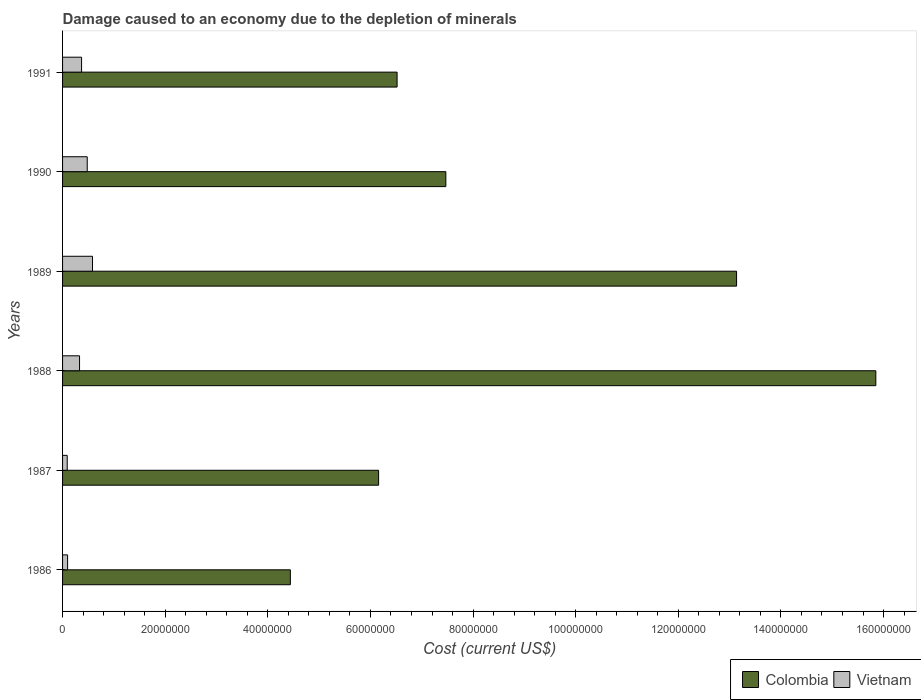How many different coloured bars are there?
Your answer should be compact. 2. How many groups of bars are there?
Make the answer very short. 6. Are the number of bars per tick equal to the number of legend labels?
Ensure brevity in your answer.  Yes. Are the number of bars on each tick of the Y-axis equal?
Provide a short and direct response. Yes. How many bars are there on the 5th tick from the bottom?
Your answer should be compact. 2. What is the cost of damage caused due to the depletion of minerals in Vietnam in 1986?
Provide a short and direct response. 9.79e+05. Across all years, what is the maximum cost of damage caused due to the depletion of minerals in Colombia?
Your response must be concise. 1.59e+08. Across all years, what is the minimum cost of damage caused due to the depletion of minerals in Colombia?
Provide a succinct answer. 4.44e+07. In which year was the cost of damage caused due to the depletion of minerals in Colombia maximum?
Make the answer very short. 1988. In which year was the cost of damage caused due to the depletion of minerals in Vietnam minimum?
Your response must be concise. 1987. What is the total cost of damage caused due to the depletion of minerals in Vietnam in the graph?
Provide a succinct answer. 1.95e+07. What is the difference between the cost of damage caused due to the depletion of minerals in Vietnam in 1987 and that in 1991?
Provide a succinct answer. -2.80e+06. What is the difference between the cost of damage caused due to the depletion of minerals in Colombia in 1991 and the cost of damage caused due to the depletion of minerals in Vietnam in 1989?
Make the answer very short. 5.94e+07. What is the average cost of damage caused due to the depletion of minerals in Vietnam per year?
Offer a terse response. 3.26e+06. In the year 1990, what is the difference between the cost of damage caused due to the depletion of minerals in Vietnam and cost of damage caused due to the depletion of minerals in Colombia?
Offer a terse response. -6.99e+07. In how many years, is the cost of damage caused due to the depletion of minerals in Colombia greater than 40000000 US$?
Your response must be concise. 6. What is the ratio of the cost of damage caused due to the depletion of minerals in Vietnam in 1986 to that in 1987?
Offer a very short reply. 1.08. Is the cost of damage caused due to the depletion of minerals in Colombia in 1986 less than that in 1989?
Make the answer very short. Yes. What is the difference between the highest and the second highest cost of damage caused due to the depletion of minerals in Colombia?
Make the answer very short. 2.71e+07. What is the difference between the highest and the lowest cost of damage caused due to the depletion of minerals in Vietnam?
Your response must be concise. 4.93e+06. In how many years, is the cost of damage caused due to the depletion of minerals in Colombia greater than the average cost of damage caused due to the depletion of minerals in Colombia taken over all years?
Provide a succinct answer. 2. Is the sum of the cost of damage caused due to the depletion of minerals in Colombia in 1988 and 1990 greater than the maximum cost of damage caused due to the depletion of minerals in Vietnam across all years?
Keep it short and to the point. Yes. What does the 1st bar from the top in 1990 represents?
Your answer should be compact. Vietnam. What does the 2nd bar from the bottom in 1990 represents?
Make the answer very short. Vietnam. How many bars are there?
Provide a succinct answer. 12. Are all the bars in the graph horizontal?
Make the answer very short. Yes. What is the difference between two consecutive major ticks on the X-axis?
Offer a very short reply. 2.00e+07. Does the graph contain any zero values?
Make the answer very short. No. How are the legend labels stacked?
Provide a succinct answer. Horizontal. What is the title of the graph?
Your response must be concise. Damage caused to an economy due to the depletion of minerals. Does "French Polynesia" appear as one of the legend labels in the graph?
Offer a very short reply. No. What is the label or title of the X-axis?
Make the answer very short. Cost (current US$). What is the label or title of the Y-axis?
Provide a short and direct response. Years. What is the Cost (current US$) of Colombia in 1986?
Offer a very short reply. 4.44e+07. What is the Cost (current US$) in Vietnam in 1986?
Your answer should be very brief. 9.79e+05. What is the Cost (current US$) in Colombia in 1987?
Ensure brevity in your answer.  6.16e+07. What is the Cost (current US$) in Vietnam in 1987?
Keep it short and to the point. 9.07e+05. What is the Cost (current US$) in Colombia in 1988?
Your answer should be compact. 1.59e+08. What is the Cost (current US$) of Vietnam in 1988?
Your response must be concise. 3.31e+06. What is the Cost (current US$) in Colombia in 1989?
Keep it short and to the point. 1.31e+08. What is the Cost (current US$) in Vietnam in 1989?
Ensure brevity in your answer.  5.84e+06. What is the Cost (current US$) in Colombia in 1990?
Offer a very short reply. 7.47e+07. What is the Cost (current US$) of Vietnam in 1990?
Provide a short and direct response. 4.81e+06. What is the Cost (current US$) in Colombia in 1991?
Offer a very short reply. 6.52e+07. What is the Cost (current US$) in Vietnam in 1991?
Offer a terse response. 3.71e+06. Across all years, what is the maximum Cost (current US$) of Colombia?
Make the answer very short. 1.59e+08. Across all years, what is the maximum Cost (current US$) in Vietnam?
Your answer should be very brief. 5.84e+06. Across all years, what is the minimum Cost (current US$) of Colombia?
Ensure brevity in your answer.  4.44e+07. Across all years, what is the minimum Cost (current US$) in Vietnam?
Keep it short and to the point. 9.07e+05. What is the total Cost (current US$) of Colombia in the graph?
Keep it short and to the point. 5.36e+08. What is the total Cost (current US$) in Vietnam in the graph?
Your response must be concise. 1.95e+07. What is the difference between the Cost (current US$) of Colombia in 1986 and that in 1987?
Your answer should be compact. -1.72e+07. What is the difference between the Cost (current US$) of Vietnam in 1986 and that in 1987?
Give a very brief answer. 7.11e+04. What is the difference between the Cost (current US$) of Colombia in 1986 and that in 1988?
Your answer should be very brief. -1.14e+08. What is the difference between the Cost (current US$) of Vietnam in 1986 and that in 1988?
Offer a terse response. -2.33e+06. What is the difference between the Cost (current US$) of Colombia in 1986 and that in 1989?
Keep it short and to the point. -8.70e+07. What is the difference between the Cost (current US$) of Vietnam in 1986 and that in 1989?
Offer a terse response. -4.86e+06. What is the difference between the Cost (current US$) of Colombia in 1986 and that in 1990?
Your answer should be very brief. -3.03e+07. What is the difference between the Cost (current US$) of Vietnam in 1986 and that in 1990?
Offer a terse response. -3.83e+06. What is the difference between the Cost (current US$) of Colombia in 1986 and that in 1991?
Your answer should be compact. -2.08e+07. What is the difference between the Cost (current US$) of Vietnam in 1986 and that in 1991?
Offer a very short reply. -2.73e+06. What is the difference between the Cost (current US$) in Colombia in 1987 and that in 1988?
Your answer should be compact. -9.69e+07. What is the difference between the Cost (current US$) of Vietnam in 1987 and that in 1988?
Offer a very short reply. -2.40e+06. What is the difference between the Cost (current US$) in Colombia in 1987 and that in 1989?
Offer a very short reply. -6.98e+07. What is the difference between the Cost (current US$) in Vietnam in 1987 and that in 1989?
Ensure brevity in your answer.  -4.93e+06. What is the difference between the Cost (current US$) of Colombia in 1987 and that in 1990?
Give a very brief answer. -1.31e+07. What is the difference between the Cost (current US$) in Vietnam in 1987 and that in 1990?
Your answer should be compact. -3.90e+06. What is the difference between the Cost (current US$) of Colombia in 1987 and that in 1991?
Make the answer very short. -3.60e+06. What is the difference between the Cost (current US$) of Vietnam in 1987 and that in 1991?
Provide a short and direct response. -2.80e+06. What is the difference between the Cost (current US$) in Colombia in 1988 and that in 1989?
Your answer should be compact. 2.71e+07. What is the difference between the Cost (current US$) in Vietnam in 1988 and that in 1989?
Your answer should be compact. -2.53e+06. What is the difference between the Cost (current US$) in Colombia in 1988 and that in 1990?
Offer a terse response. 8.38e+07. What is the difference between the Cost (current US$) in Vietnam in 1988 and that in 1990?
Provide a succinct answer. -1.50e+06. What is the difference between the Cost (current US$) in Colombia in 1988 and that in 1991?
Ensure brevity in your answer.  9.33e+07. What is the difference between the Cost (current US$) of Vietnam in 1988 and that in 1991?
Your answer should be very brief. -3.96e+05. What is the difference between the Cost (current US$) in Colombia in 1989 and that in 1990?
Give a very brief answer. 5.67e+07. What is the difference between the Cost (current US$) of Vietnam in 1989 and that in 1990?
Your answer should be very brief. 1.03e+06. What is the difference between the Cost (current US$) in Colombia in 1989 and that in 1991?
Offer a very short reply. 6.62e+07. What is the difference between the Cost (current US$) of Vietnam in 1989 and that in 1991?
Ensure brevity in your answer.  2.13e+06. What is the difference between the Cost (current US$) of Colombia in 1990 and that in 1991?
Provide a short and direct response. 9.50e+06. What is the difference between the Cost (current US$) in Vietnam in 1990 and that in 1991?
Provide a succinct answer. 1.10e+06. What is the difference between the Cost (current US$) in Colombia in 1986 and the Cost (current US$) in Vietnam in 1987?
Ensure brevity in your answer.  4.35e+07. What is the difference between the Cost (current US$) of Colombia in 1986 and the Cost (current US$) of Vietnam in 1988?
Your response must be concise. 4.11e+07. What is the difference between the Cost (current US$) of Colombia in 1986 and the Cost (current US$) of Vietnam in 1989?
Your answer should be compact. 3.86e+07. What is the difference between the Cost (current US$) of Colombia in 1986 and the Cost (current US$) of Vietnam in 1990?
Your answer should be very brief. 3.96e+07. What is the difference between the Cost (current US$) of Colombia in 1986 and the Cost (current US$) of Vietnam in 1991?
Your answer should be compact. 4.07e+07. What is the difference between the Cost (current US$) in Colombia in 1987 and the Cost (current US$) in Vietnam in 1988?
Ensure brevity in your answer.  5.83e+07. What is the difference between the Cost (current US$) in Colombia in 1987 and the Cost (current US$) in Vietnam in 1989?
Your response must be concise. 5.58e+07. What is the difference between the Cost (current US$) in Colombia in 1987 and the Cost (current US$) in Vietnam in 1990?
Give a very brief answer. 5.68e+07. What is the difference between the Cost (current US$) of Colombia in 1987 and the Cost (current US$) of Vietnam in 1991?
Offer a terse response. 5.79e+07. What is the difference between the Cost (current US$) in Colombia in 1988 and the Cost (current US$) in Vietnam in 1989?
Provide a succinct answer. 1.53e+08. What is the difference between the Cost (current US$) of Colombia in 1988 and the Cost (current US$) of Vietnam in 1990?
Your response must be concise. 1.54e+08. What is the difference between the Cost (current US$) in Colombia in 1988 and the Cost (current US$) in Vietnam in 1991?
Provide a succinct answer. 1.55e+08. What is the difference between the Cost (current US$) of Colombia in 1989 and the Cost (current US$) of Vietnam in 1990?
Offer a terse response. 1.27e+08. What is the difference between the Cost (current US$) in Colombia in 1989 and the Cost (current US$) in Vietnam in 1991?
Offer a terse response. 1.28e+08. What is the difference between the Cost (current US$) of Colombia in 1990 and the Cost (current US$) of Vietnam in 1991?
Provide a succinct answer. 7.10e+07. What is the average Cost (current US$) of Colombia per year?
Keep it short and to the point. 8.93e+07. What is the average Cost (current US$) in Vietnam per year?
Make the answer very short. 3.26e+06. In the year 1986, what is the difference between the Cost (current US$) in Colombia and Cost (current US$) in Vietnam?
Your response must be concise. 4.34e+07. In the year 1987, what is the difference between the Cost (current US$) in Colombia and Cost (current US$) in Vietnam?
Give a very brief answer. 6.07e+07. In the year 1988, what is the difference between the Cost (current US$) in Colombia and Cost (current US$) in Vietnam?
Give a very brief answer. 1.55e+08. In the year 1989, what is the difference between the Cost (current US$) in Colombia and Cost (current US$) in Vietnam?
Ensure brevity in your answer.  1.26e+08. In the year 1990, what is the difference between the Cost (current US$) in Colombia and Cost (current US$) in Vietnam?
Your answer should be very brief. 6.99e+07. In the year 1991, what is the difference between the Cost (current US$) in Colombia and Cost (current US$) in Vietnam?
Offer a very short reply. 6.15e+07. What is the ratio of the Cost (current US$) of Colombia in 1986 to that in 1987?
Your response must be concise. 0.72. What is the ratio of the Cost (current US$) of Vietnam in 1986 to that in 1987?
Offer a very short reply. 1.08. What is the ratio of the Cost (current US$) of Colombia in 1986 to that in 1988?
Provide a short and direct response. 0.28. What is the ratio of the Cost (current US$) in Vietnam in 1986 to that in 1988?
Your answer should be very brief. 0.3. What is the ratio of the Cost (current US$) of Colombia in 1986 to that in 1989?
Give a very brief answer. 0.34. What is the ratio of the Cost (current US$) of Vietnam in 1986 to that in 1989?
Give a very brief answer. 0.17. What is the ratio of the Cost (current US$) of Colombia in 1986 to that in 1990?
Your answer should be compact. 0.59. What is the ratio of the Cost (current US$) in Vietnam in 1986 to that in 1990?
Your response must be concise. 0.2. What is the ratio of the Cost (current US$) in Colombia in 1986 to that in 1991?
Give a very brief answer. 0.68. What is the ratio of the Cost (current US$) in Vietnam in 1986 to that in 1991?
Your response must be concise. 0.26. What is the ratio of the Cost (current US$) of Colombia in 1987 to that in 1988?
Your answer should be very brief. 0.39. What is the ratio of the Cost (current US$) of Vietnam in 1987 to that in 1988?
Your answer should be very brief. 0.27. What is the ratio of the Cost (current US$) of Colombia in 1987 to that in 1989?
Provide a short and direct response. 0.47. What is the ratio of the Cost (current US$) of Vietnam in 1987 to that in 1989?
Provide a succinct answer. 0.16. What is the ratio of the Cost (current US$) of Colombia in 1987 to that in 1990?
Ensure brevity in your answer.  0.82. What is the ratio of the Cost (current US$) in Vietnam in 1987 to that in 1990?
Keep it short and to the point. 0.19. What is the ratio of the Cost (current US$) in Colombia in 1987 to that in 1991?
Ensure brevity in your answer.  0.94. What is the ratio of the Cost (current US$) in Vietnam in 1987 to that in 1991?
Your answer should be very brief. 0.24. What is the ratio of the Cost (current US$) in Colombia in 1988 to that in 1989?
Provide a succinct answer. 1.21. What is the ratio of the Cost (current US$) in Vietnam in 1988 to that in 1989?
Provide a succinct answer. 0.57. What is the ratio of the Cost (current US$) in Colombia in 1988 to that in 1990?
Make the answer very short. 2.12. What is the ratio of the Cost (current US$) in Vietnam in 1988 to that in 1990?
Make the answer very short. 0.69. What is the ratio of the Cost (current US$) in Colombia in 1988 to that in 1991?
Your answer should be compact. 2.43. What is the ratio of the Cost (current US$) in Vietnam in 1988 to that in 1991?
Your answer should be compact. 0.89. What is the ratio of the Cost (current US$) in Colombia in 1989 to that in 1990?
Keep it short and to the point. 1.76. What is the ratio of the Cost (current US$) in Vietnam in 1989 to that in 1990?
Your response must be concise. 1.21. What is the ratio of the Cost (current US$) of Colombia in 1989 to that in 1991?
Make the answer very short. 2.01. What is the ratio of the Cost (current US$) in Vietnam in 1989 to that in 1991?
Your response must be concise. 1.57. What is the ratio of the Cost (current US$) in Colombia in 1990 to that in 1991?
Your answer should be very brief. 1.15. What is the ratio of the Cost (current US$) in Vietnam in 1990 to that in 1991?
Offer a very short reply. 1.3. What is the difference between the highest and the second highest Cost (current US$) in Colombia?
Provide a succinct answer. 2.71e+07. What is the difference between the highest and the second highest Cost (current US$) of Vietnam?
Your answer should be compact. 1.03e+06. What is the difference between the highest and the lowest Cost (current US$) in Colombia?
Offer a very short reply. 1.14e+08. What is the difference between the highest and the lowest Cost (current US$) in Vietnam?
Ensure brevity in your answer.  4.93e+06. 